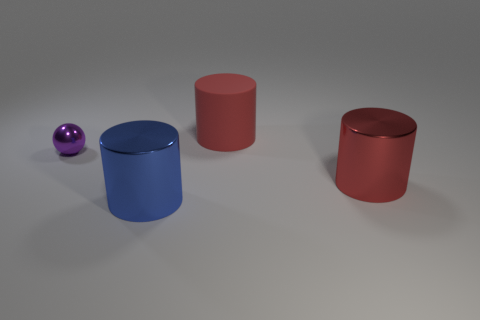Subtract all large metallic cylinders. How many cylinders are left? 1 How many red cylinders must be subtracted to get 1 red cylinders? 1 Subtract 1 spheres. How many spheres are left? 0 Subtract all brown cylinders. Subtract all yellow spheres. How many cylinders are left? 3 Subtract all gray cubes. How many red cylinders are left? 2 Subtract all large red rubber cylinders. Subtract all green objects. How many objects are left? 3 Add 2 blue metallic things. How many blue metallic things are left? 3 Add 3 large red metal cylinders. How many large red metal cylinders exist? 4 Add 3 blue matte cubes. How many objects exist? 7 Subtract all blue cylinders. How many cylinders are left? 2 